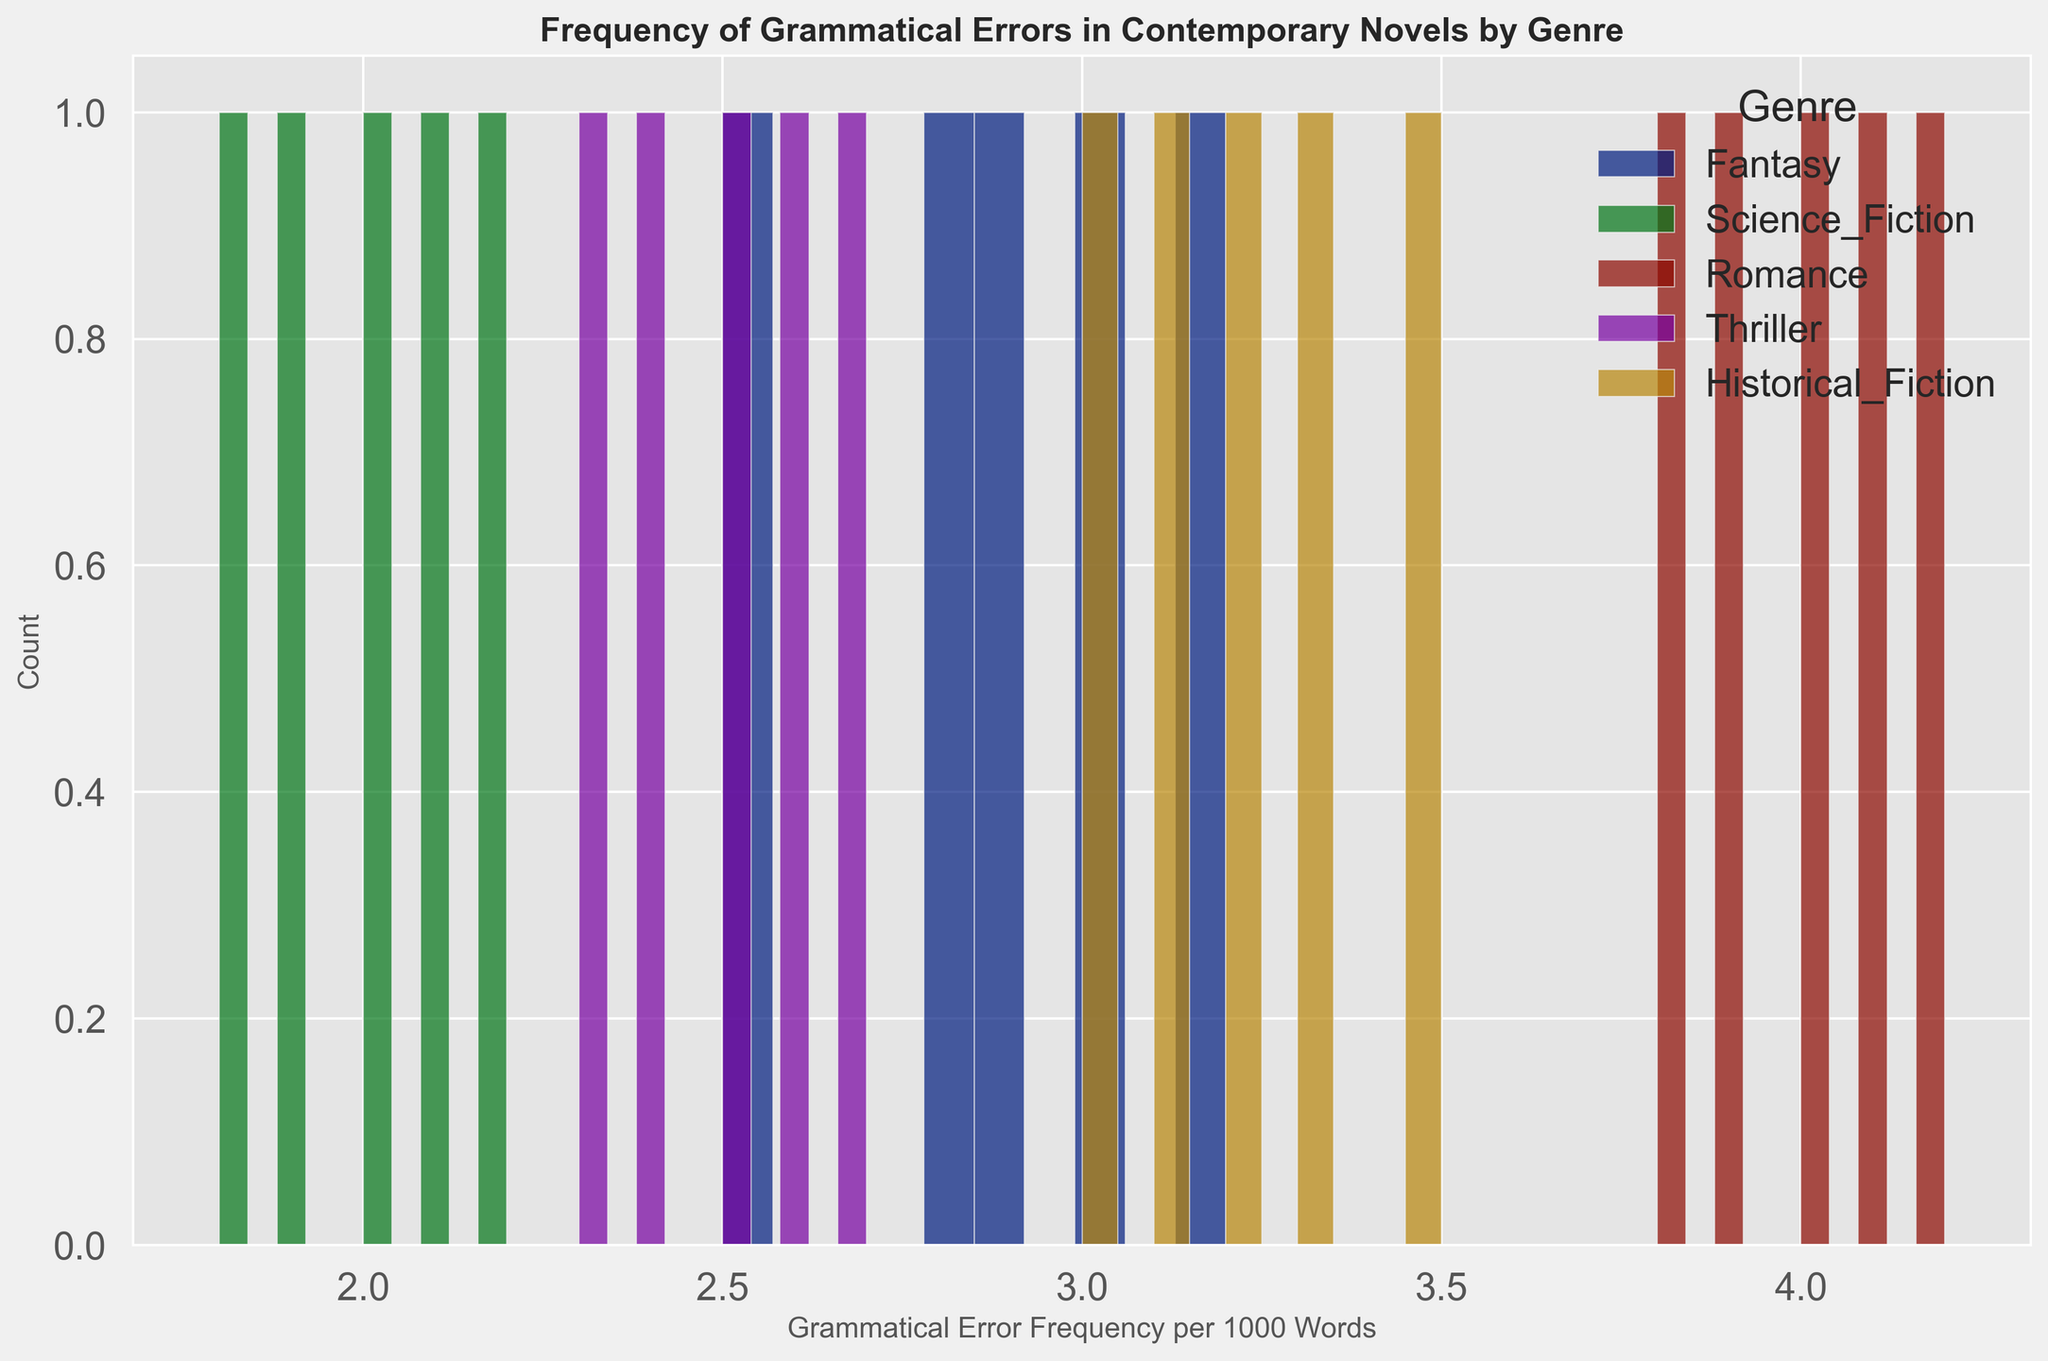Which genre shows the highest frequency of grammatical errors per 1000 words? By examining the histogram, the bars representing the "Romance" genre stretch higher on the frequency axis compared to others, indicating a higher grammatical error frequency.
Answer: Romance Which genre has the lowest average frequency of grammatical errors per 1000 words? To determine this, compare each genre's average frequency of grammatical errors as plotted in the histogram. "Science Fiction" has bars positioned lower on the grammatical error frequency axis than other genres.
Answer: Science Fiction Do any genres have overlapping ranges of grammatical error frequencies? Visual inspection of the histogram shows that "Fantasy" and "Thriller" have overlapping error frequency ranges. Both have bars between approximately 2.3 and 2.9 errors per 1000 words.
Answer: Yes How does the frequency of grammatical errors in "Historical Fiction" compare to "Fantasy"? By assessing the histogram, "Historical Fiction" generally has a higher error frequency (3.0-3.5) compared to "Fantasy" (2.5-3.2).
Answer: Higher Which genre shows the widest spread in grammatical error frequencies? Observing the histograms, "Romance" spans a range from 3.8 to 4.2 errors per 1000 words, wider than others.
Answer: Romance What's the difference in the average grammatical error frequency between "Romance" and "Thriller"? The average frequency for "Romance" is around 4.0, and for "Thriller," it is around 2.5. The difference is 4.0 - 2.5.
Answer: 1.5 What can be inferred about the consistency of grammatical error frequencies within each genre? "Science Fiction" shows a narrow range of frequencies around 2.0, indicating high consistency, whereas "Romance" has a wider range, showing less consistency.
Answer: Science Fiction is most consistent, Romance is least consistent Which genre has the most data points with error frequencies around 3.0? Evaluating the histogram, "Historical Fiction" has frequencies clustering around the 3.0 mark more than other genres, signifying the most data points at this frequency.
Answer: Historical Fiction 